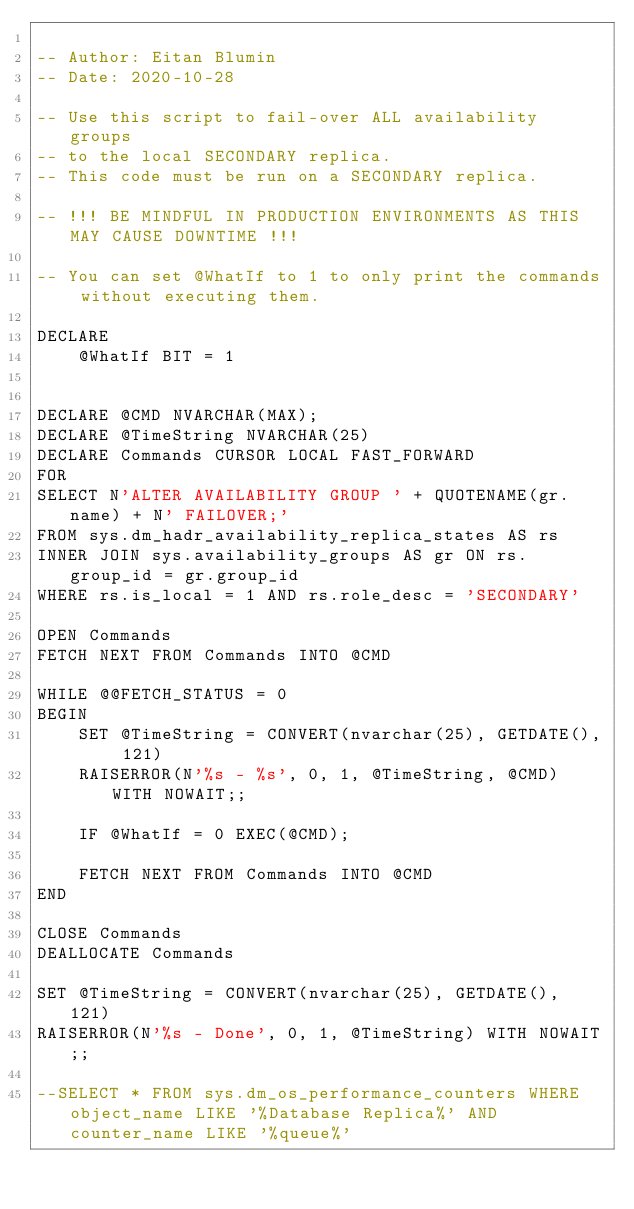Convert code to text. <code><loc_0><loc_0><loc_500><loc_500><_SQL_>
-- Author: Eitan Blumin
-- Date: 2020-10-28

-- Use this script to fail-over ALL availability groups
-- to the local SECONDARY replica.
-- This code must be run on a SECONDARY replica.

-- !!! BE MINDFUL IN PRODUCTION ENVIRONMENTS AS THIS MAY CAUSE DOWNTIME !!!

-- You can set @WhatIf to 1 to only print the commands without executing them.

DECLARE
	@WhatIf BIT = 1

	  
DECLARE @CMD NVARCHAR(MAX);
DECLARE @TimeString NVARCHAR(25)
DECLARE Commands CURSOR LOCAL FAST_FORWARD
FOR
SELECT N'ALTER AVAILABILITY GROUP ' + QUOTENAME(gr.name) + N' FAILOVER;'
FROM sys.dm_hadr_availability_replica_states AS rs
INNER JOIN sys.availability_groups AS gr ON rs.group_id = gr.group_id
WHERE rs.is_local = 1 AND rs.role_desc = 'SECONDARY'

OPEN Commands
FETCH NEXT FROM Commands INTO @CMD

WHILE @@FETCH_STATUS = 0
BEGIN
	SET @TimeString = CONVERT(nvarchar(25), GETDATE(), 121)
	RAISERROR(N'%s - %s', 0, 1, @TimeString, @CMD) WITH NOWAIT;;

	IF @WhatIf = 0 EXEC(@CMD);

	FETCH NEXT FROM Commands INTO @CMD
END

CLOSE Commands
DEALLOCATE Commands

SET @TimeString = CONVERT(nvarchar(25), GETDATE(), 121)
RAISERROR(N'%s - Done', 0, 1, @TimeString) WITH NOWAIT;;

--SELECT * FROM sys.dm_os_performance_counters WHERE object_name LIKE '%Database Replica%' AND counter_name LIKE '%queue%'</code> 